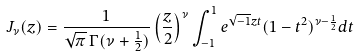<formula> <loc_0><loc_0><loc_500><loc_500>J _ { \nu } ( z ) = \frac { 1 } { \sqrt { \pi } \, \Gamma ( \nu + \frac { 1 } { 2 } ) } \left ( \frac { z } { 2 } \right ) ^ { \nu } \int _ { - 1 } ^ { 1 } e ^ { \sqrt { - 1 } z t } ( 1 - t ^ { 2 } ) ^ { \nu - \frac { 1 } { 2 } } d t</formula> 